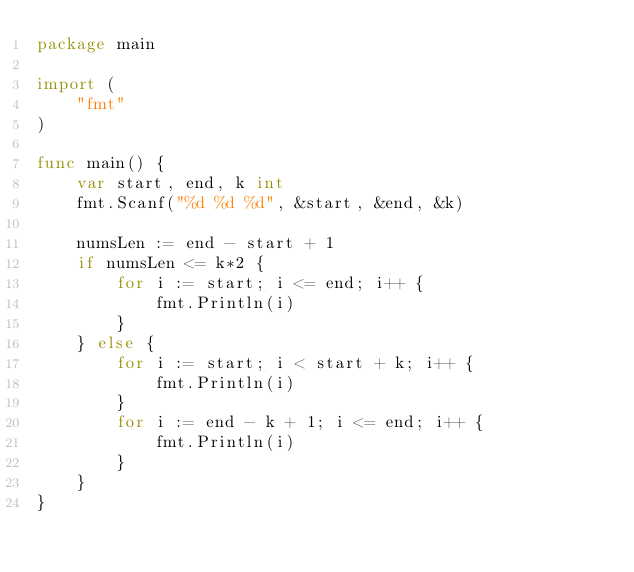Convert code to text. <code><loc_0><loc_0><loc_500><loc_500><_Go_>package main

import (
    "fmt"
)

func main() {
    var start, end, k int
    fmt.Scanf("%d %d %d", &start, &end, &k)

    numsLen := end - start + 1
    if numsLen <= k*2 {
        for i := start; i <= end; i++ {
            fmt.Println(i)
        }
    } else {
        for i := start; i < start + k; i++ {
            fmt.Println(i)
        }
        for i := end - k + 1; i <= end; i++ {
            fmt.Println(i)
        }
    }
}
</code> 